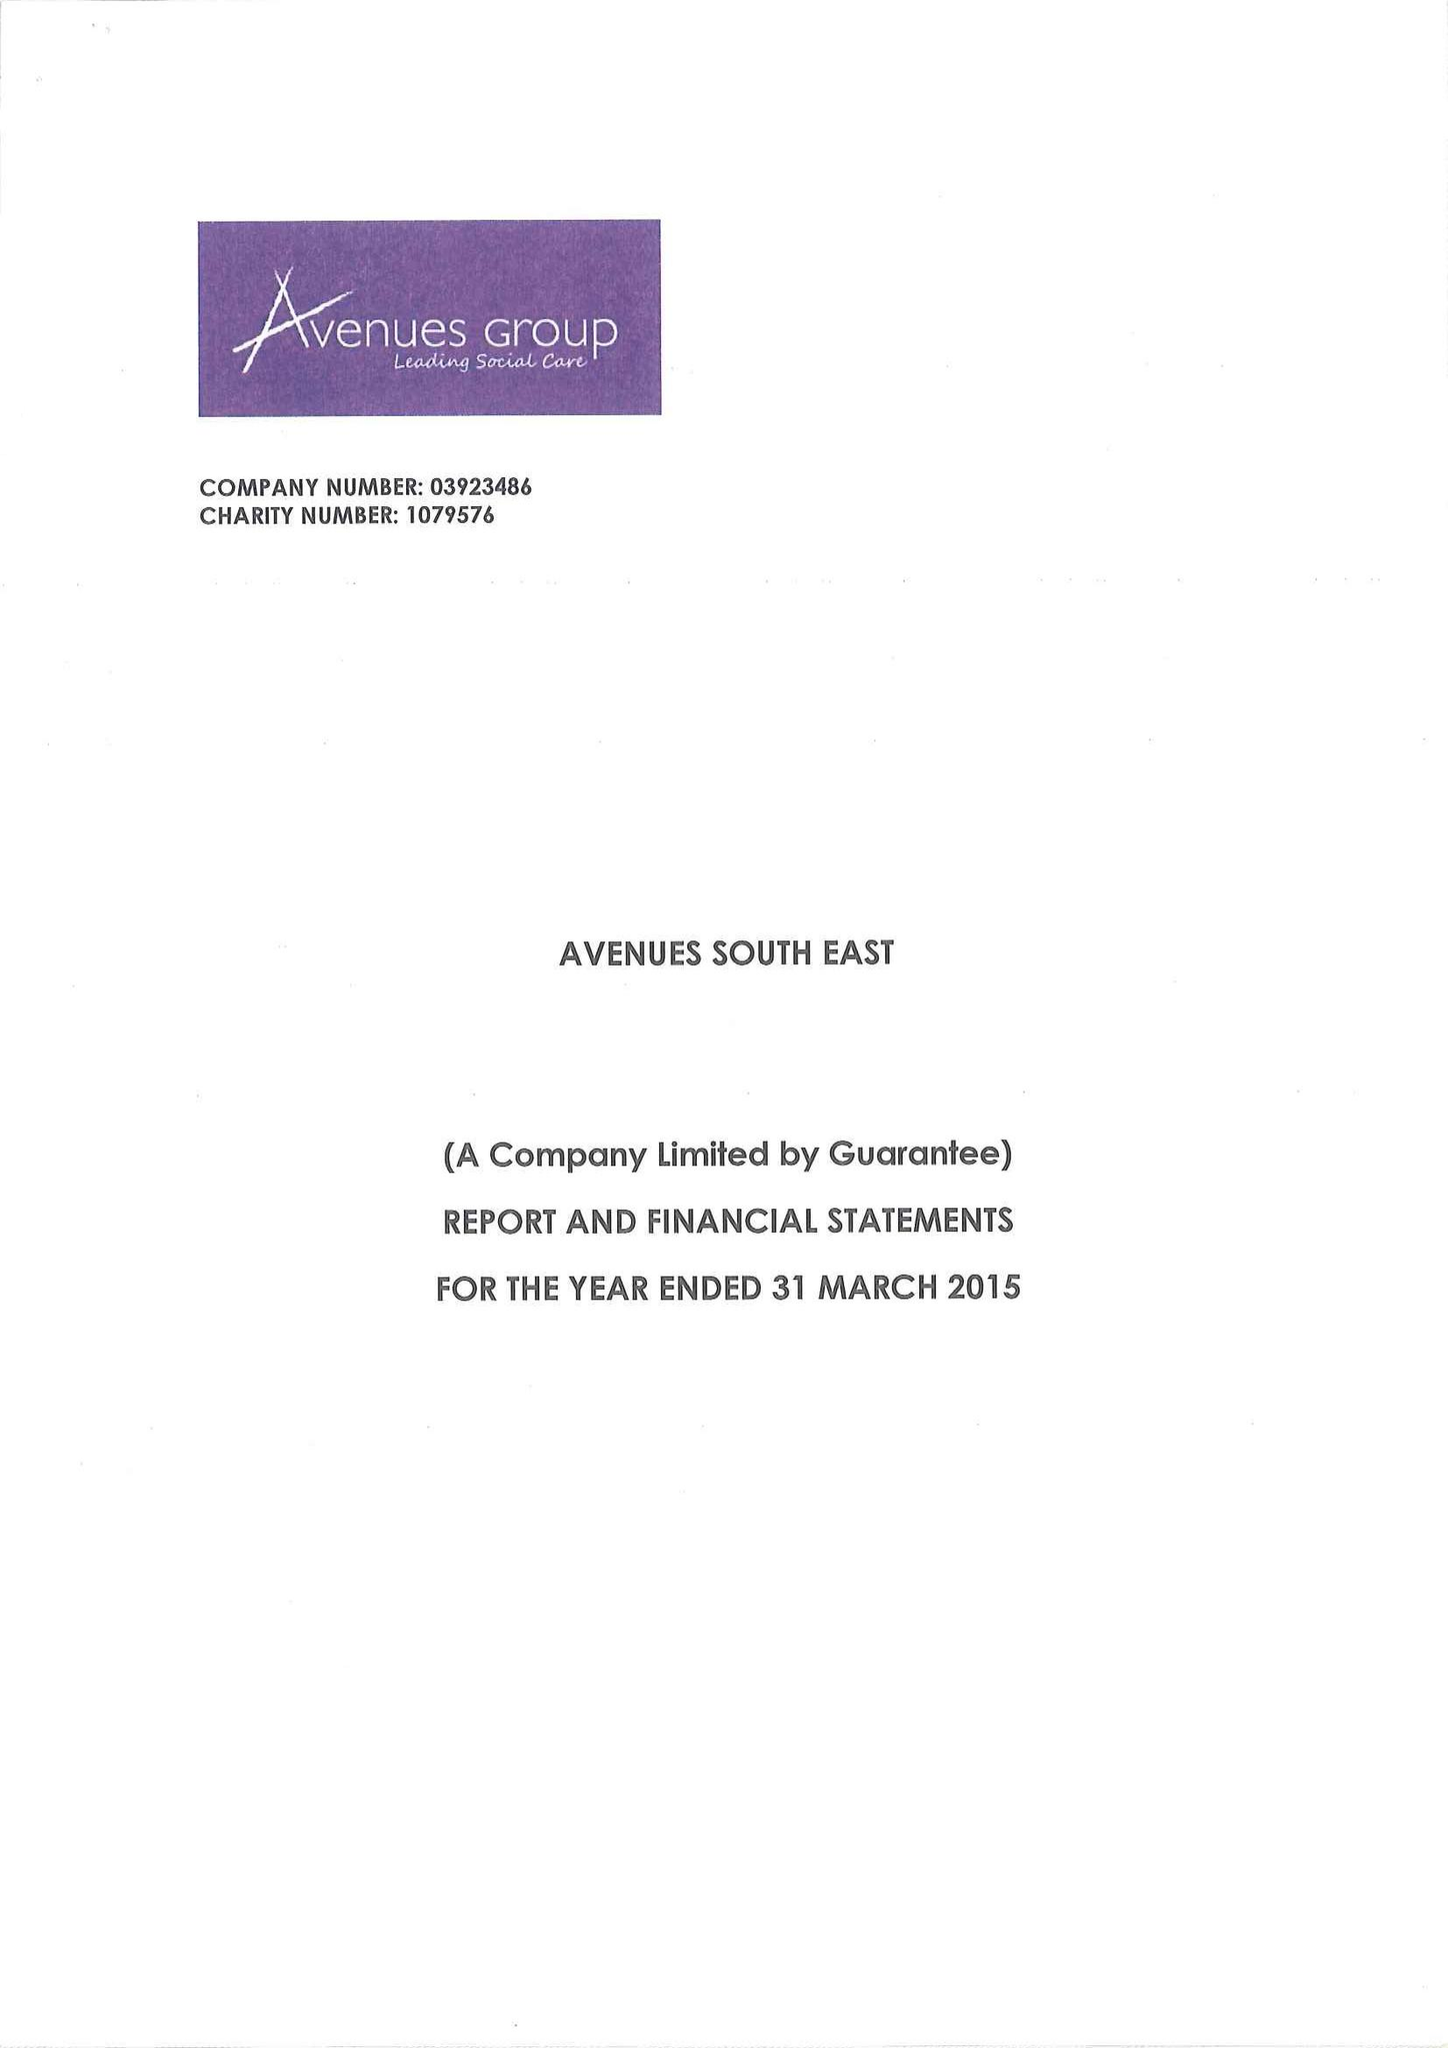What is the value for the income_annually_in_british_pounds?
Answer the question using a single word or phrase. 13963212.00 